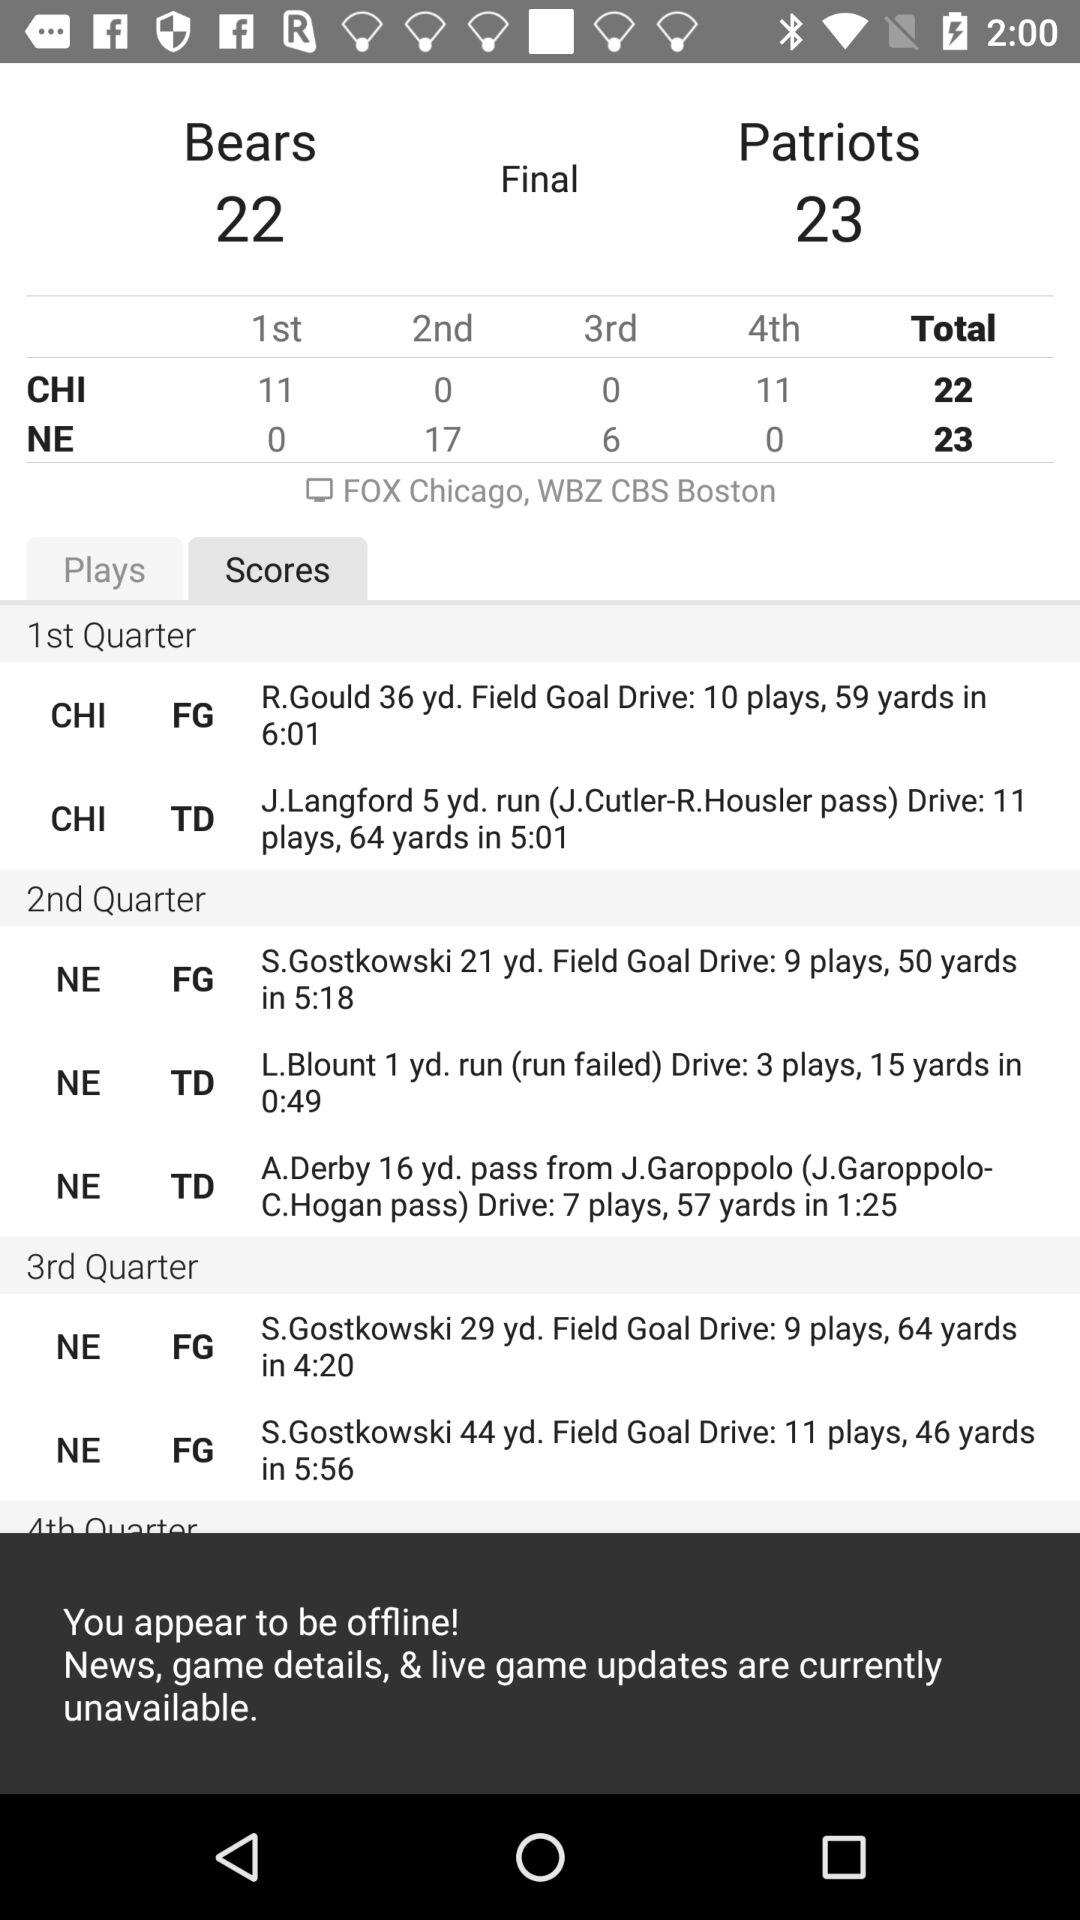Which teams are competing in the final? The teams competing in the final are the "Bears" and "Patriots". 